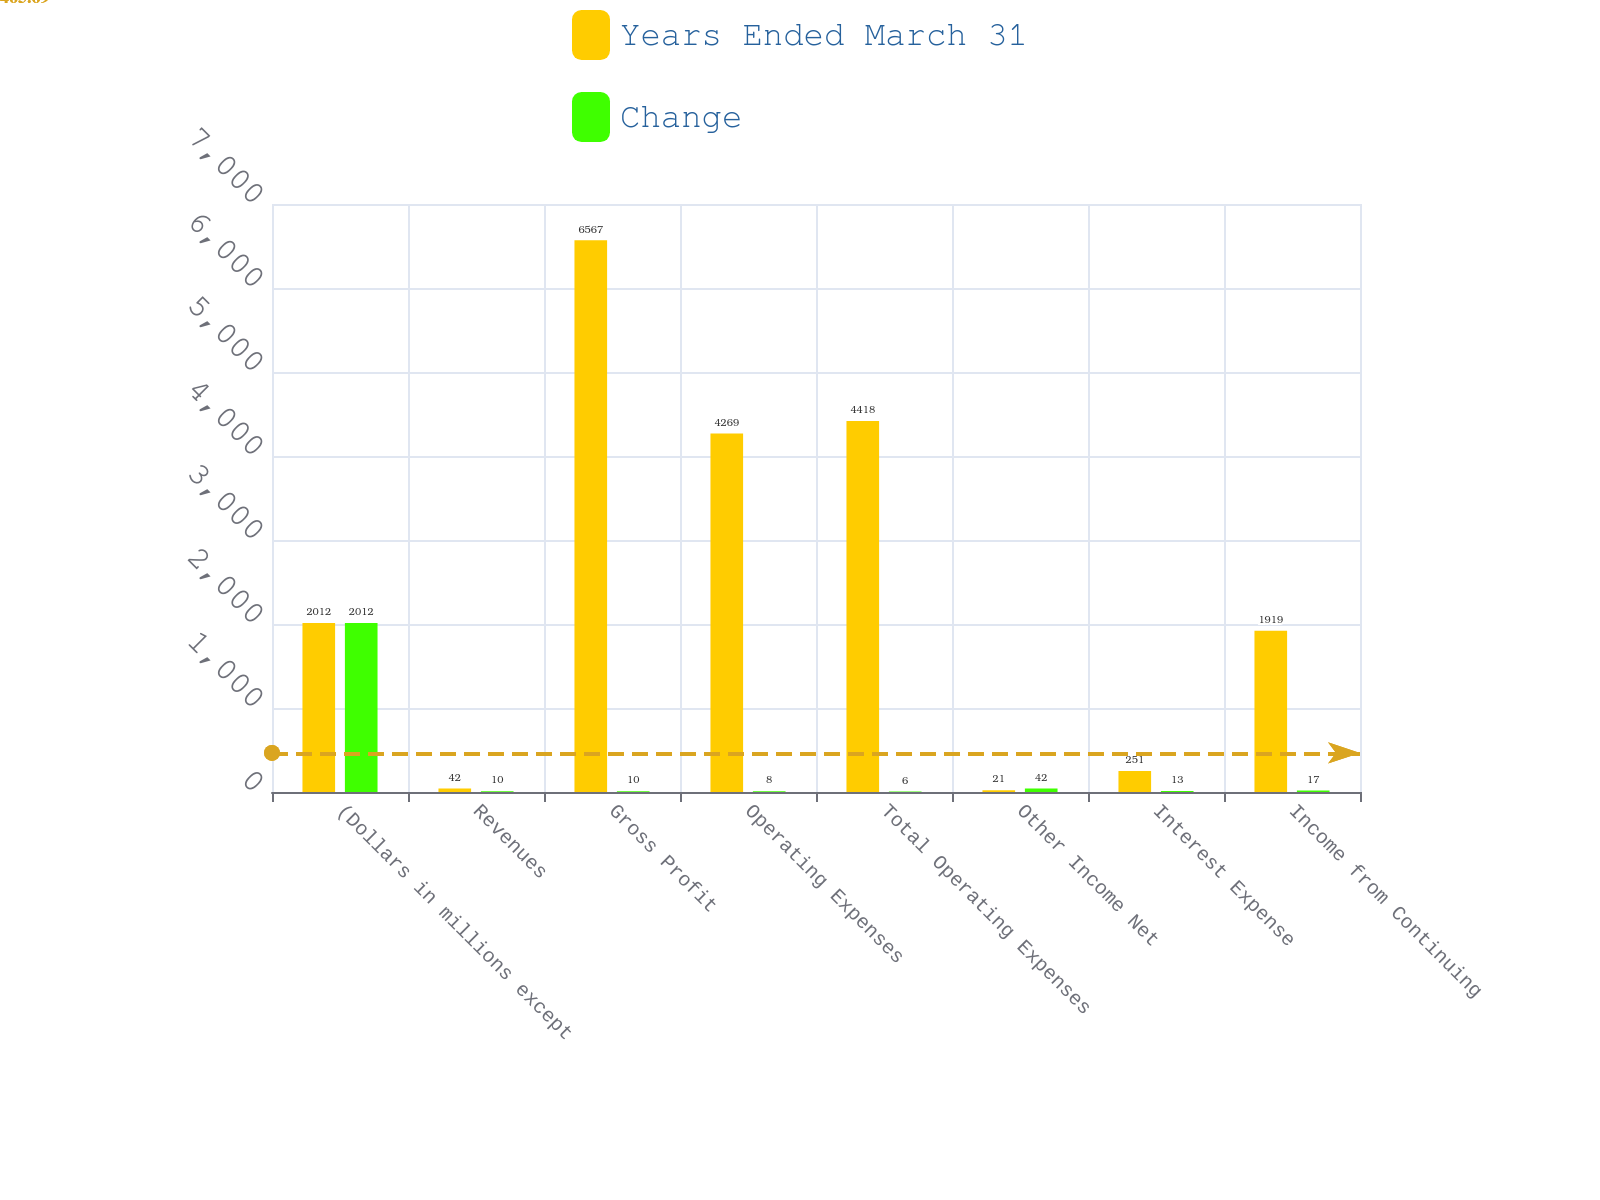<chart> <loc_0><loc_0><loc_500><loc_500><stacked_bar_chart><ecel><fcel>(Dollars in millions except<fcel>Revenues<fcel>Gross Profit<fcel>Operating Expenses<fcel>Total Operating Expenses<fcel>Other Income Net<fcel>Interest Expense<fcel>Income from Continuing<nl><fcel>Years Ended March 31<fcel>2012<fcel>42<fcel>6567<fcel>4269<fcel>4418<fcel>21<fcel>251<fcel>1919<nl><fcel>Change<fcel>2012<fcel>10<fcel>10<fcel>8<fcel>6<fcel>42<fcel>13<fcel>17<nl></chart> 